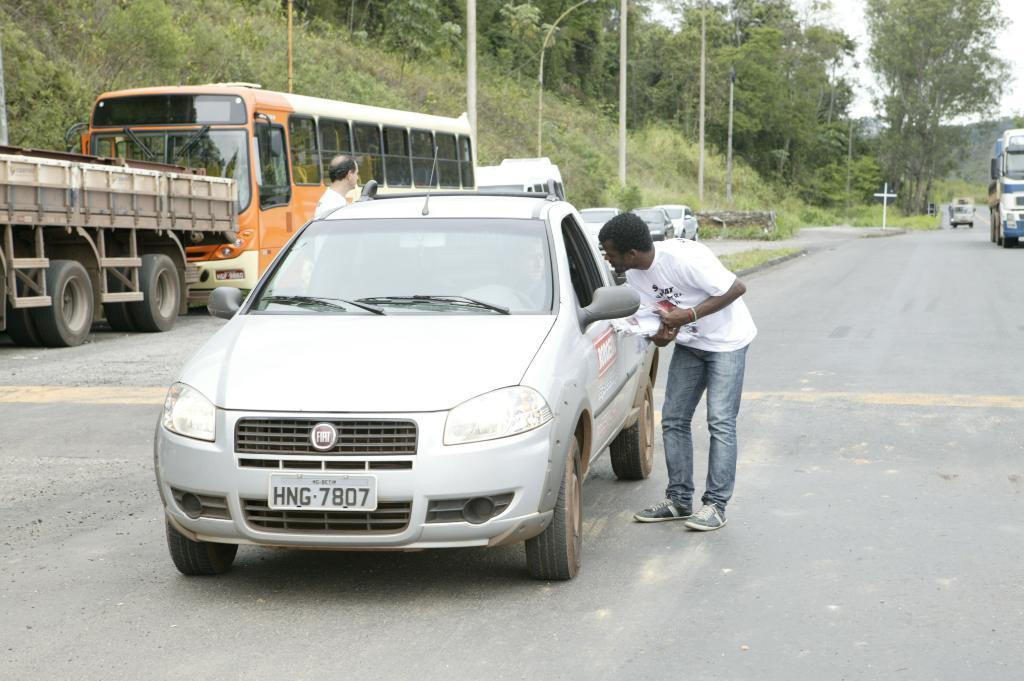How would you summarize this image in a sentence or two? In this image I can see a m an is standing next to a car. In the background I can see number of vehicles, trees, street poles and here one more person is standing. 